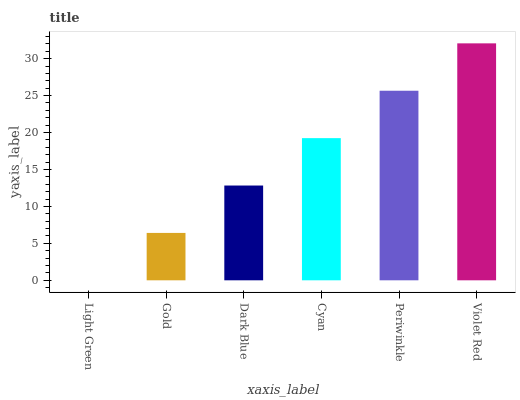Is Light Green the minimum?
Answer yes or no. Yes. Is Violet Red the maximum?
Answer yes or no. Yes. Is Gold the minimum?
Answer yes or no. No. Is Gold the maximum?
Answer yes or no. No. Is Gold greater than Light Green?
Answer yes or no. Yes. Is Light Green less than Gold?
Answer yes or no. Yes. Is Light Green greater than Gold?
Answer yes or no. No. Is Gold less than Light Green?
Answer yes or no. No. Is Cyan the high median?
Answer yes or no. Yes. Is Dark Blue the low median?
Answer yes or no. Yes. Is Light Green the high median?
Answer yes or no. No. Is Gold the low median?
Answer yes or no. No. 